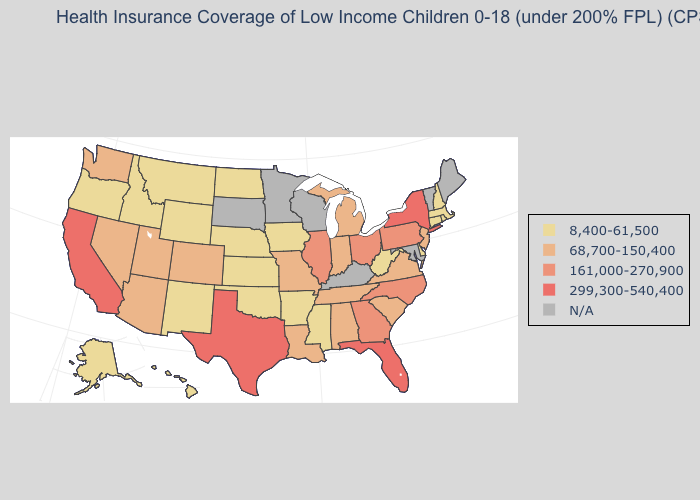Among the states that border New Mexico , which have the highest value?
Concise answer only. Texas. What is the value of Texas?
Short answer required. 299,300-540,400. What is the value of Tennessee?
Answer briefly. 68,700-150,400. Among the states that border Alabama , does Florida have the lowest value?
Write a very short answer. No. Among the states that border Pennsylvania , does Delaware have the lowest value?
Quick response, please. Yes. Name the states that have a value in the range 161,000-270,900?
Short answer required. Georgia, Illinois, North Carolina, Ohio, Pennsylvania. Does Colorado have the lowest value in the West?
Quick response, please. No. Name the states that have a value in the range N/A?
Answer briefly. Kentucky, Maine, Maryland, Minnesota, South Dakota, Vermont, Wisconsin. What is the value of Michigan?
Be succinct. 68,700-150,400. What is the value of Georgia?
Write a very short answer. 161,000-270,900. What is the lowest value in the West?
Short answer required. 8,400-61,500. Among the states that border Oklahoma , does Kansas have the highest value?
Be succinct. No. Name the states that have a value in the range 161,000-270,900?
Keep it brief. Georgia, Illinois, North Carolina, Ohio, Pennsylvania. Name the states that have a value in the range 299,300-540,400?
Concise answer only. California, Florida, New York, Texas. 